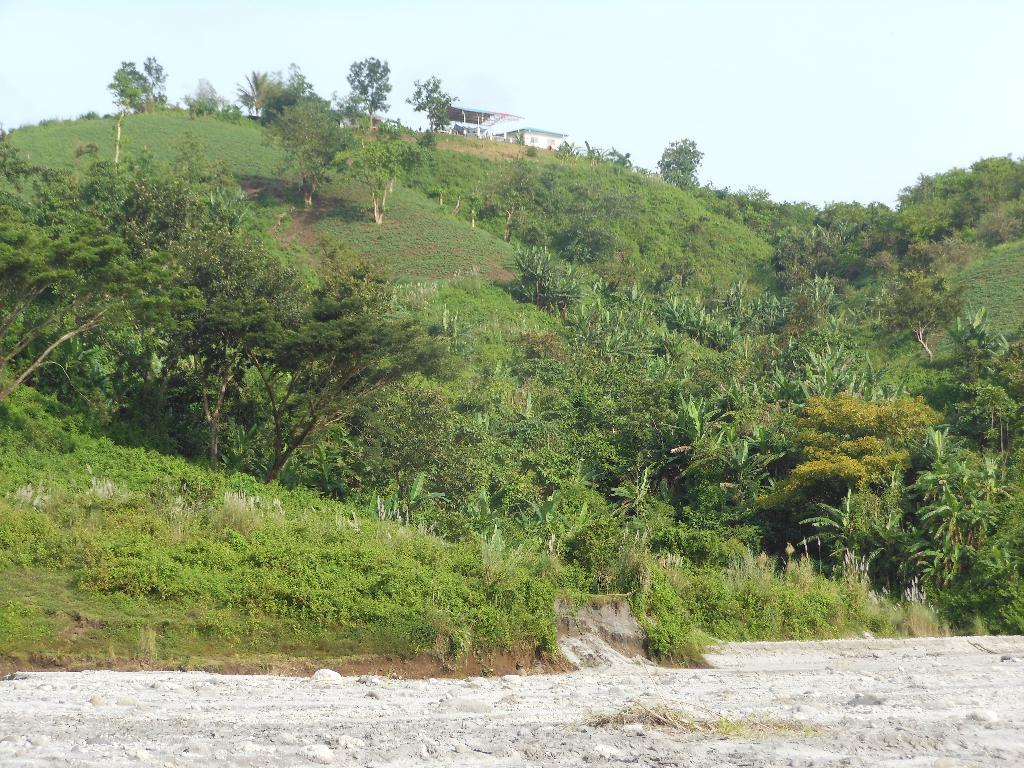What type of vegetation is present on the hill in the image? There are trees and plants on the hill in the image. What structure can be seen on top of the hill? There appears to be a house on top of the hill in the image. What is visible in the background of the image? The sky is visible in the background of the image. Can you see a river flowing through the house in the image? There is no river visible in the image, and the house is not shown to have any water flowing through it. What type of crack is present on the hill in the image? There is no crack visible on the hill in the image. 